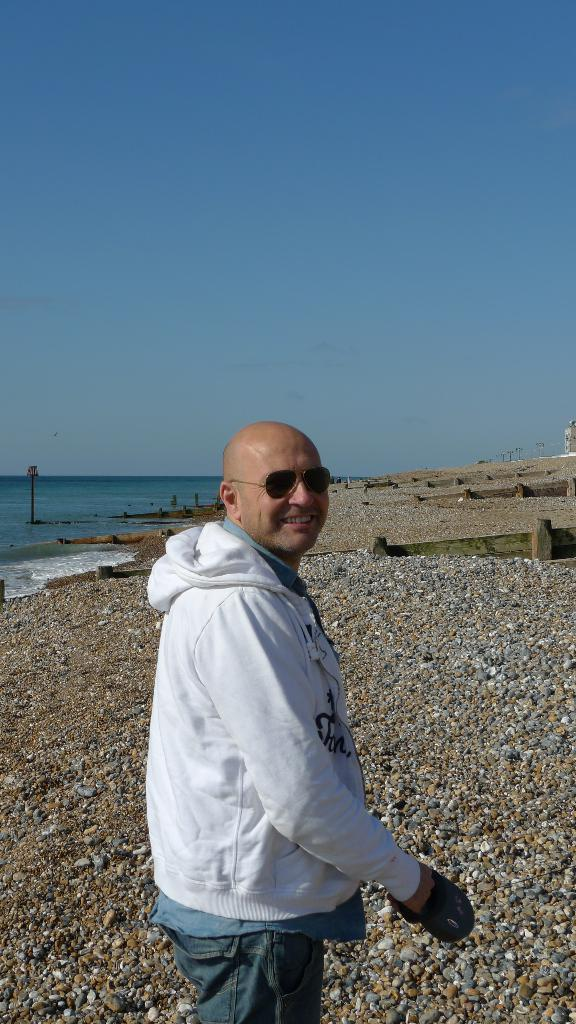Who is present in the image? There is a man in the image. What is the man wearing on his face? The man is wearing sunglasses. What is the man holding in his hand? The man is holding something in his hand, but we cannot determine what it is from the image. What can be seen in the background of the image? There is water visible in the image. What type of ground surface is present in the image? There are stones on the ground in the image. What color is the sky in the image? The sky is blue in the image. What type of force is being applied to the man's toe in the image? There is no indication of any force being applied to the man's toe in the image. 